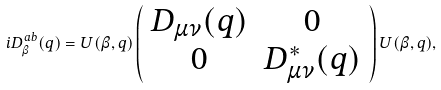Convert formula to latex. <formula><loc_0><loc_0><loc_500><loc_500>i D _ { \beta } ^ { a b } ( q ) = U ( \beta , q ) \left ( \begin{array} { c c } D _ { \mu \nu } ( q ) & 0 \\ 0 & D _ { \mu \nu } ^ { * } ( q ) \end{array} \right ) U ( \beta , q ) ,</formula> 